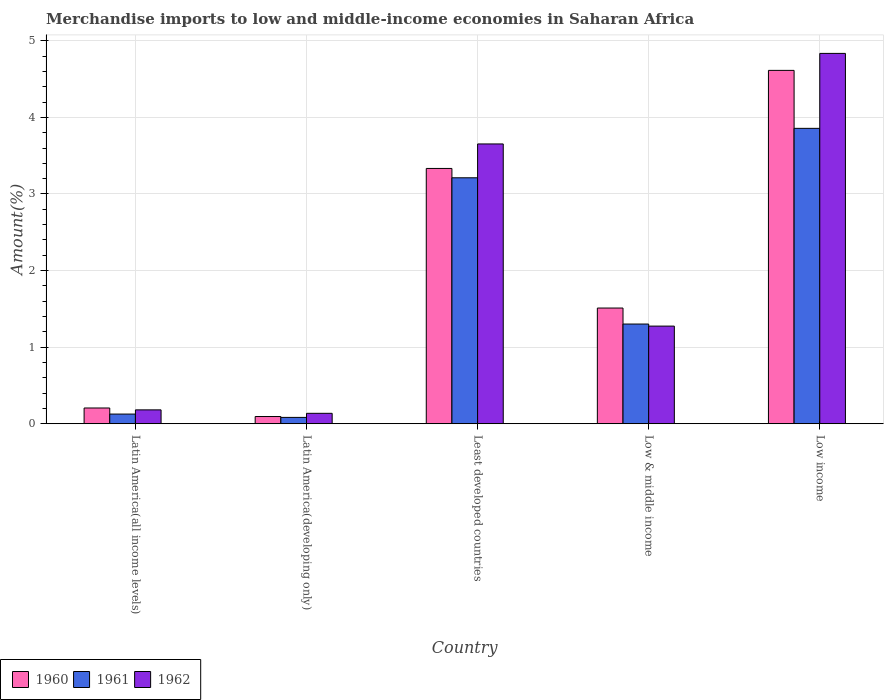Are the number of bars per tick equal to the number of legend labels?
Your answer should be very brief. Yes. Are the number of bars on each tick of the X-axis equal?
Your response must be concise. Yes. How many bars are there on the 1st tick from the right?
Your answer should be compact. 3. In how many cases, is the number of bars for a given country not equal to the number of legend labels?
Make the answer very short. 0. What is the percentage of amount earned from merchandise imports in 1962 in Latin America(all income levels)?
Provide a succinct answer. 0.18. Across all countries, what is the maximum percentage of amount earned from merchandise imports in 1961?
Provide a short and direct response. 3.86. Across all countries, what is the minimum percentage of amount earned from merchandise imports in 1962?
Give a very brief answer. 0.14. In which country was the percentage of amount earned from merchandise imports in 1961 maximum?
Ensure brevity in your answer.  Low income. In which country was the percentage of amount earned from merchandise imports in 1962 minimum?
Your response must be concise. Latin America(developing only). What is the total percentage of amount earned from merchandise imports in 1962 in the graph?
Give a very brief answer. 10.08. What is the difference between the percentage of amount earned from merchandise imports in 1962 in Latin America(developing only) and that in Low income?
Provide a short and direct response. -4.7. What is the difference between the percentage of amount earned from merchandise imports in 1960 in Least developed countries and the percentage of amount earned from merchandise imports in 1961 in Low & middle income?
Give a very brief answer. 2.03. What is the average percentage of amount earned from merchandise imports in 1961 per country?
Ensure brevity in your answer.  1.72. What is the difference between the percentage of amount earned from merchandise imports of/in 1961 and percentage of amount earned from merchandise imports of/in 1962 in Least developed countries?
Make the answer very short. -0.44. In how many countries, is the percentage of amount earned from merchandise imports in 1962 greater than 2.4 %?
Provide a succinct answer. 2. What is the ratio of the percentage of amount earned from merchandise imports in 1960 in Least developed countries to that in Low & middle income?
Your response must be concise. 2.21. Is the difference between the percentage of amount earned from merchandise imports in 1961 in Latin America(all income levels) and Low income greater than the difference between the percentage of amount earned from merchandise imports in 1962 in Latin America(all income levels) and Low income?
Offer a terse response. Yes. What is the difference between the highest and the second highest percentage of amount earned from merchandise imports in 1962?
Your response must be concise. -2.38. What is the difference between the highest and the lowest percentage of amount earned from merchandise imports in 1960?
Offer a terse response. 4.52. In how many countries, is the percentage of amount earned from merchandise imports in 1960 greater than the average percentage of amount earned from merchandise imports in 1960 taken over all countries?
Your response must be concise. 2. What does the 2nd bar from the left in Latin America(developing only) represents?
Provide a short and direct response. 1961. What does the 3rd bar from the right in Low & middle income represents?
Provide a succinct answer. 1960. Is it the case that in every country, the sum of the percentage of amount earned from merchandise imports in 1961 and percentage of amount earned from merchandise imports in 1962 is greater than the percentage of amount earned from merchandise imports in 1960?
Provide a succinct answer. Yes. What is the difference between two consecutive major ticks on the Y-axis?
Keep it short and to the point. 1. Are the values on the major ticks of Y-axis written in scientific E-notation?
Keep it short and to the point. No. Does the graph contain any zero values?
Your answer should be very brief. No. Where does the legend appear in the graph?
Make the answer very short. Bottom left. What is the title of the graph?
Your answer should be very brief. Merchandise imports to low and middle-income economies in Saharan Africa. Does "2008" appear as one of the legend labels in the graph?
Your answer should be compact. No. What is the label or title of the Y-axis?
Offer a terse response. Amount(%). What is the Amount(%) of 1960 in Latin America(all income levels)?
Provide a short and direct response. 0.21. What is the Amount(%) in 1961 in Latin America(all income levels)?
Provide a short and direct response. 0.13. What is the Amount(%) in 1962 in Latin America(all income levels)?
Your answer should be very brief. 0.18. What is the Amount(%) of 1960 in Latin America(developing only)?
Keep it short and to the point. 0.09. What is the Amount(%) of 1961 in Latin America(developing only)?
Offer a terse response. 0.08. What is the Amount(%) of 1962 in Latin America(developing only)?
Your response must be concise. 0.14. What is the Amount(%) of 1960 in Least developed countries?
Your answer should be compact. 3.33. What is the Amount(%) in 1961 in Least developed countries?
Ensure brevity in your answer.  3.21. What is the Amount(%) of 1962 in Least developed countries?
Offer a terse response. 3.65. What is the Amount(%) in 1960 in Low & middle income?
Keep it short and to the point. 1.51. What is the Amount(%) in 1961 in Low & middle income?
Keep it short and to the point. 1.3. What is the Amount(%) in 1962 in Low & middle income?
Provide a short and direct response. 1.27. What is the Amount(%) in 1960 in Low income?
Give a very brief answer. 4.61. What is the Amount(%) in 1961 in Low income?
Offer a very short reply. 3.86. What is the Amount(%) in 1962 in Low income?
Offer a very short reply. 4.84. Across all countries, what is the maximum Amount(%) in 1960?
Your answer should be very brief. 4.61. Across all countries, what is the maximum Amount(%) in 1961?
Ensure brevity in your answer.  3.86. Across all countries, what is the maximum Amount(%) of 1962?
Your answer should be compact. 4.84. Across all countries, what is the minimum Amount(%) in 1960?
Your answer should be compact. 0.09. Across all countries, what is the minimum Amount(%) of 1961?
Your response must be concise. 0.08. Across all countries, what is the minimum Amount(%) in 1962?
Give a very brief answer. 0.14. What is the total Amount(%) of 1960 in the graph?
Provide a succinct answer. 9.76. What is the total Amount(%) of 1961 in the graph?
Offer a very short reply. 8.58. What is the total Amount(%) of 1962 in the graph?
Provide a short and direct response. 10.08. What is the difference between the Amount(%) in 1960 in Latin America(all income levels) and that in Latin America(developing only)?
Offer a terse response. 0.11. What is the difference between the Amount(%) in 1961 in Latin America(all income levels) and that in Latin America(developing only)?
Ensure brevity in your answer.  0.04. What is the difference between the Amount(%) in 1962 in Latin America(all income levels) and that in Latin America(developing only)?
Your answer should be very brief. 0.05. What is the difference between the Amount(%) in 1960 in Latin America(all income levels) and that in Least developed countries?
Give a very brief answer. -3.13. What is the difference between the Amount(%) in 1961 in Latin America(all income levels) and that in Least developed countries?
Your answer should be compact. -3.08. What is the difference between the Amount(%) of 1962 in Latin America(all income levels) and that in Least developed countries?
Your answer should be very brief. -3.47. What is the difference between the Amount(%) in 1960 in Latin America(all income levels) and that in Low & middle income?
Keep it short and to the point. -1.3. What is the difference between the Amount(%) of 1961 in Latin America(all income levels) and that in Low & middle income?
Your answer should be very brief. -1.18. What is the difference between the Amount(%) of 1962 in Latin America(all income levels) and that in Low & middle income?
Offer a terse response. -1.09. What is the difference between the Amount(%) in 1960 in Latin America(all income levels) and that in Low income?
Keep it short and to the point. -4.41. What is the difference between the Amount(%) in 1961 in Latin America(all income levels) and that in Low income?
Offer a very short reply. -3.73. What is the difference between the Amount(%) of 1962 in Latin America(all income levels) and that in Low income?
Offer a very short reply. -4.65. What is the difference between the Amount(%) of 1960 in Latin America(developing only) and that in Least developed countries?
Give a very brief answer. -3.24. What is the difference between the Amount(%) of 1961 in Latin America(developing only) and that in Least developed countries?
Ensure brevity in your answer.  -3.13. What is the difference between the Amount(%) in 1962 in Latin America(developing only) and that in Least developed countries?
Ensure brevity in your answer.  -3.52. What is the difference between the Amount(%) of 1960 in Latin America(developing only) and that in Low & middle income?
Ensure brevity in your answer.  -1.42. What is the difference between the Amount(%) in 1961 in Latin America(developing only) and that in Low & middle income?
Your answer should be very brief. -1.22. What is the difference between the Amount(%) of 1962 in Latin America(developing only) and that in Low & middle income?
Offer a very short reply. -1.14. What is the difference between the Amount(%) in 1960 in Latin America(developing only) and that in Low income?
Keep it short and to the point. -4.52. What is the difference between the Amount(%) of 1961 in Latin America(developing only) and that in Low income?
Your answer should be compact. -3.77. What is the difference between the Amount(%) of 1962 in Latin America(developing only) and that in Low income?
Make the answer very short. -4.7. What is the difference between the Amount(%) in 1960 in Least developed countries and that in Low & middle income?
Your response must be concise. 1.82. What is the difference between the Amount(%) in 1961 in Least developed countries and that in Low & middle income?
Make the answer very short. 1.91. What is the difference between the Amount(%) of 1962 in Least developed countries and that in Low & middle income?
Provide a succinct answer. 2.38. What is the difference between the Amount(%) of 1960 in Least developed countries and that in Low income?
Keep it short and to the point. -1.28. What is the difference between the Amount(%) in 1961 in Least developed countries and that in Low income?
Provide a short and direct response. -0.65. What is the difference between the Amount(%) of 1962 in Least developed countries and that in Low income?
Your answer should be very brief. -1.18. What is the difference between the Amount(%) of 1960 in Low & middle income and that in Low income?
Keep it short and to the point. -3.1. What is the difference between the Amount(%) of 1961 in Low & middle income and that in Low income?
Your response must be concise. -2.56. What is the difference between the Amount(%) of 1962 in Low & middle income and that in Low income?
Your answer should be compact. -3.56. What is the difference between the Amount(%) in 1960 in Latin America(all income levels) and the Amount(%) in 1961 in Latin America(developing only)?
Give a very brief answer. 0.12. What is the difference between the Amount(%) in 1960 in Latin America(all income levels) and the Amount(%) in 1962 in Latin America(developing only)?
Keep it short and to the point. 0.07. What is the difference between the Amount(%) of 1961 in Latin America(all income levels) and the Amount(%) of 1962 in Latin America(developing only)?
Your answer should be very brief. -0.01. What is the difference between the Amount(%) of 1960 in Latin America(all income levels) and the Amount(%) of 1961 in Least developed countries?
Make the answer very short. -3.01. What is the difference between the Amount(%) in 1960 in Latin America(all income levels) and the Amount(%) in 1962 in Least developed countries?
Your answer should be compact. -3.45. What is the difference between the Amount(%) in 1961 in Latin America(all income levels) and the Amount(%) in 1962 in Least developed countries?
Keep it short and to the point. -3.53. What is the difference between the Amount(%) in 1960 in Latin America(all income levels) and the Amount(%) in 1961 in Low & middle income?
Your answer should be compact. -1.1. What is the difference between the Amount(%) in 1960 in Latin America(all income levels) and the Amount(%) in 1962 in Low & middle income?
Provide a succinct answer. -1.07. What is the difference between the Amount(%) of 1961 in Latin America(all income levels) and the Amount(%) of 1962 in Low & middle income?
Keep it short and to the point. -1.15. What is the difference between the Amount(%) of 1960 in Latin America(all income levels) and the Amount(%) of 1961 in Low income?
Offer a terse response. -3.65. What is the difference between the Amount(%) in 1960 in Latin America(all income levels) and the Amount(%) in 1962 in Low income?
Your response must be concise. -4.63. What is the difference between the Amount(%) in 1961 in Latin America(all income levels) and the Amount(%) in 1962 in Low income?
Provide a short and direct response. -4.71. What is the difference between the Amount(%) in 1960 in Latin America(developing only) and the Amount(%) in 1961 in Least developed countries?
Provide a short and direct response. -3.12. What is the difference between the Amount(%) of 1960 in Latin America(developing only) and the Amount(%) of 1962 in Least developed countries?
Keep it short and to the point. -3.56. What is the difference between the Amount(%) of 1961 in Latin America(developing only) and the Amount(%) of 1962 in Least developed countries?
Give a very brief answer. -3.57. What is the difference between the Amount(%) of 1960 in Latin America(developing only) and the Amount(%) of 1961 in Low & middle income?
Your answer should be very brief. -1.21. What is the difference between the Amount(%) of 1960 in Latin America(developing only) and the Amount(%) of 1962 in Low & middle income?
Provide a succinct answer. -1.18. What is the difference between the Amount(%) in 1961 in Latin America(developing only) and the Amount(%) in 1962 in Low & middle income?
Your answer should be compact. -1.19. What is the difference between the Amount(%) in 1960 in Latin America(developing only) and the Amount(%) in 1961 in Low income?
Make the answer very short. -3.76. What is the difference between the Amount(%) in 1960 in Latin America(developing only) and the Amount(%) in 1962 in Low income?
Make the answer very short. -4.74. What is the difference between the Amount(%) in 1961 in Latin America(developing only) and the Amount(%) in 1962 in Low income?
Provide a short and direct response. -4.75. What is the difference between the Amount(%) of 1960 in Least developed countries and the Amount(%) of 1961 in Low & middle income?
Your answer should be very brief. 2.03. What is the difference between the Amount(%) of 1960 in Least developed countries and the Amount(%) of 1962 in Low & middle income?
Your answer should be very brief. 2.06. What is the difference between the Amount(%) of 1961 in Least developed countries and the Amount(%) of 1962 in Low & middle income?
Your response must be concise. 1.94. What is the difference between the Amount(%) of 1960 in Least developed countries and the Amount(%) of 1961 in Low income?
Provide a short and direct response. -0.52. What is the difference between the Amount(%) of 1960 in Least developed countries and the Amount(%) of 1962 in Low income?
Give a very brief answer. -1.5. What is the difference between the Amount(%) of 1961 in Least developed countries and the Amount(%) of 1962 in Low income?
Make the answer very short. -1.62. What is the difference between the Amount(%) in 1960 in Low & middle income and the Amount(%) in 1961 in Low income?
Your answer should be very brief. -2.35. What is the difference between the Amount(%) in 1960 in Low & middle income and the Amount(%) in 1962 in Low income?
Keep it short and to the point. -3.32. What is the difference between the Amount(%) in 1961 in Low & middle income and the Amount(%) in 1962 in Low income?
Keep it short and to the point. -3.53. What is the average Amount(%) of 1960 per country?
Make the answer very short. 1.95. What is the average Amount(%) in 1961 per country?
Give a very brief answer. 1.72. What is the average Amount(%) in 1962 per country?
Provide a succinct answer. 2.02. What is the difference between the Amount(%) of 1960 and Amount(%) of 1961 in Latin America(all income levels)?
Your answer should be compact. 0.08. What is the difference between the Amount(%) in 1960 and Amount(%) in 1962 in Latin America(all income levels)?
Make the answer very short. 0.02. What is the difference between the Amount(%) of 1961 and Amount(%) of 1962 in Latin America(all income levels)?
Your answer should be very brief. -0.05. What is the difference between the Amount(%) in 1960 and Amount(%) in 1961 in Latin America(developing only)?
Offer a very short reply. 0.01. What is the difference between the Amount(%) of 1960 and Amount(%) of 1962 in Latin America(developing only)?
Keep it short and to the point. -0.04. What is the difference between the Amount(%) of 1961 and Amount(%) of 1962 in Latin America(developing only)?
Ensure brevity in your answer.  -0.05. What is the difference between the Amount(%) in 1960 and Amount(%) in 1961 in Least developed countries?
Give a very brief answer. 0.12. What is the difference between the Amount(%) in 1960 and Amount(%) in 1962 in Least developed countries?
Provide a short and direct response. -0.32. What is the difference between the Amount(%) of 1961 and Amount(%) of 1962 in Least developed countries?
Make the answer very short. -0.44. What is the difference between the Amount(%) of 1960 and Amount(%) of 1961 in Low & middle income?
Offer a terse response. 0.21. What is the difference between the Amount(%) in 1960 and Amount(%) in 1962 in Low & middle income?
Give a very brief answer. 0.24. What is the difference between the Amount(%) of 1961 and Amount(%) of 1962 in Low & middle income?
Keep it short and to the point. 0.03. What is the difference between the Amount(%) of 1960 and Amount(%) of 1961 in Low income?
Provide a short and direct response. 0.76. What is the difference between the Amount(%) of 1960 and Amount(%) of 1962 in Low income?
Your response must be concise. -0.22. What is the difference between the Amount(%) in 1961 and Amount(%) in 1962 in Low income?
Offer a very short reply. -0.98. What is the ratio of the Amount(%) of 1960 in Latin America(all income levels) to that in Latin America(developing only)?
Your answer should be compact. 2.18. What is the ratio of the Amount(%) in 1961 in Latin America(all income levels) to that in Latin America(developing only)?
Keep it short and to the point. 1.53. What is the ratio of the Amount(%) in 1962 in Latin America(all income levels) to that in Latin America(developing only)?
Your answer should be compact. 1.33. What is the ratio of the Amount(%) of 1960 in Latin America(all income levels) to that in Least developed countries?
Provide a succinct answer. 0.06. What is the ratio of the Amount(%) in 1961 in Latin America(all income levels) to that in Least developed countries?
Keep it short and to the point. 0.04. What is the ratio of the Amount(%) of 1962 in Latin America(all income levels) to that in Least developed countries?
Offer a terse response. 0.05. What is the ratio of the Amount(%) in 1960 in Latin America(all income levels) to that in Low & middle income?
Ensure brevity in your answer.  0.14. What is the ratio of the Amount(%) of 1961 in Latin America(all income levels) to that in Low & middle income?
Your answer should be compact. 0.1. What is the ratio of the Amount(%) in 1962 in Latin America(all income levels) to that in Low & middle income?
Offer a terse response. 0.14. What is the ratio of the Amount(%) of 1960 in Latin America(all income levels) to that in Low income?
Your answer should be compact. 0.04. What is the ratio of the Amount(%) in 1961 in Latin America(all income levels) to that in Low income?
Make the answer very short. 0.03. What is the ratio of the Amount(%) in 1962 in Latin America(all income levels) to that in Low income?
Give a very brief answer. 0.04. What is the ratio of the Amount(%) in 1960 in Latin America(developing only) to that in Least developed countries?
Give a very brief answer. 0.03. What is the ratio of the Amount(%) in 1961 in Latin America(developing only) to that in Least developed countries?
Ensure brevity in your answer.  0.03. What is the ratio of the Amount(%) of 1962 in Latin America(developing only) to that in Least developed countries?
Give a very brief answer. 0.04. What is the ratio of the Amount(%) of 1960 in Latin America(developing only) to that in Low & middle income?
Give a very brief answer. 0.06. What is the ratio of the Amount(%) in 1961 in Latin America(developing only) to that in Low & middle income?
Give a very brief answer. 0.06. What is the ratio of the Amount(%) in 1962 in Latin America(developing only) to that in Low & middle income?
Your response must be concise. 0.11. What is the ratio of the Amount(%) in 1960 in Latin America(developing only) to that in Low income?
Your answer should be compact. 0.02. What is the ratio of the Amount(%) in 1961 in Latin America(developing only) to that in Low income?
Offer a terse response. 0.02. What is the ratio of the Amount(%) in 1962 in Latin America(developing only) to that in Low income?
Keep it short and to the point. 0.03. What is the ratio of the Amount(%) in 1960 in Least developed countries to that in Low & middle income?
Ensure brevity in your answer.  2.21. What is the ratio of the Amount(%) of 1961 in Least developed countries to that in Low & middle income?
Provide a short and direct response. 2.47. What is the ratio of the Amount(%) in 1962 in Least developed countries to that in Low & middle income?
Your answer should be compact. 2.87. What is the ratio of the Amount(%) of 1960 in Least developed countries to that in Low income?
Your answer should be very brief. 0.72. What is the ratio of the Amount(%) in 1961 in Least developed countries to that in Low income?
Ensure brevity in your answer.  0.83. What is the ratio of the Amount(%) in 1962 in Least developed countries to that in Low income?
Provide a short and direct response. 0.76. What is the ratio of the Amount(%) of 1960 in Low & middle income to that in Low income?
Give a very brief answer. 0.33. What is the ratio of the Amount(%) in 1961 in Low & middle income to that in Low income?
Your answer should be compact. 0.34. What is the ratio of the Amount(%) in 1962 in Low & middle income to that in Low income?
Your answer should be very brief. 0.26. What is the difference between the highest and the second highest Amount(%) of 1960?
Offer a terse response. 1.28. What is the difference between the highest and the second highest Amount(%) in 1961?
Offer a terse response. 0.65. What is the difference between the highest and the second highest Amount(%) of 1962?
Offer a terse response. 1.18. What is the difference between the highest and the lowest Amount(%) in 1960?
Your response must be concise. 4.52. What is the difference between the highest and the lowest Amount(%) in 1961?
Your response must be concise. 3.77. What is the difference between the highest and the lowest Amount(%) of 1962?
Ensure brevity in your answer.  4.7. 